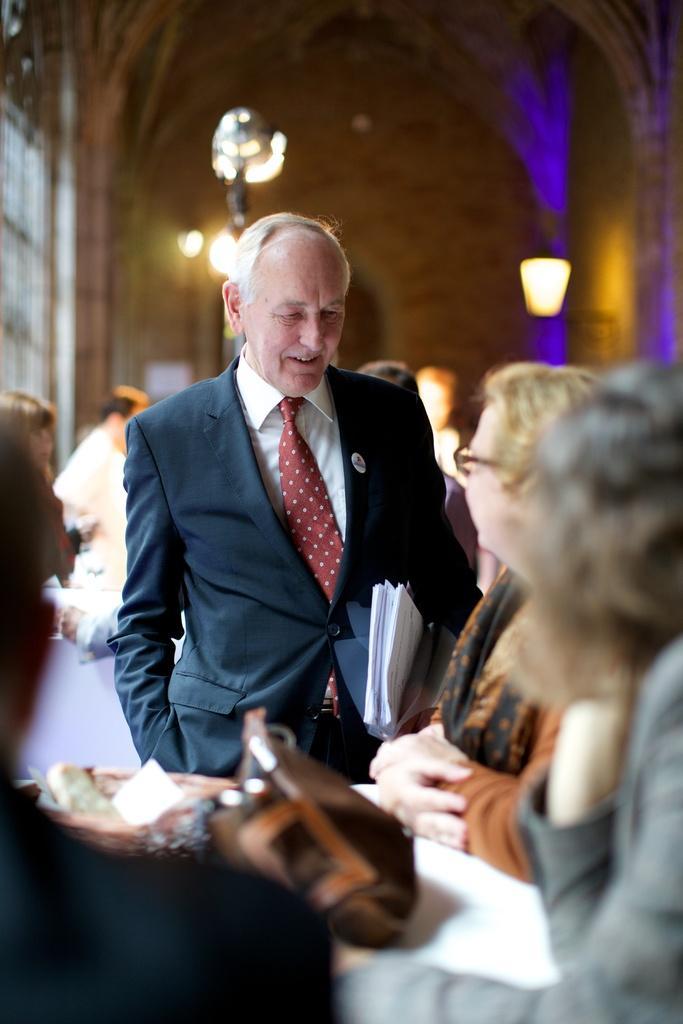Please provide a concise description of this image. This picture shows few people standing and we see women and a handbag on the table and we see man holding papers in his hand and we see lights and a basket on the table. 